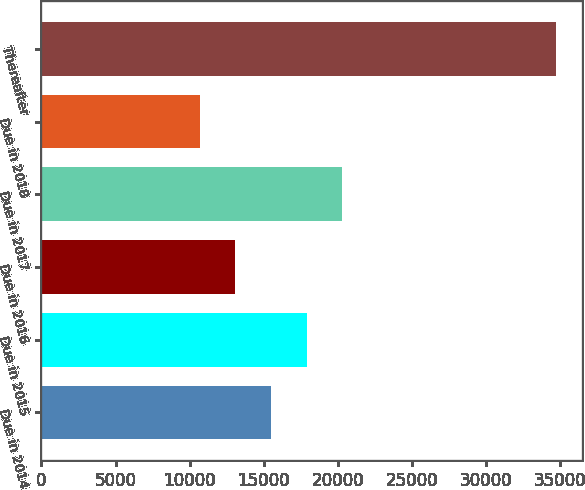<chart> <loc_0><loc_0><loc_500><loc_500><bar_chart><fcel>Due in 2014<fcel>Due in 2015<fcel>Due in 2016<fcel>Due in 2017<fcel>Due in 2018<fcel>Thereafter<nl><fcel>15500.8<fcel>17906.7<fcel>13094.9<fcel>20312.6<fcel>10689<fcel>34748<nl></chart> 